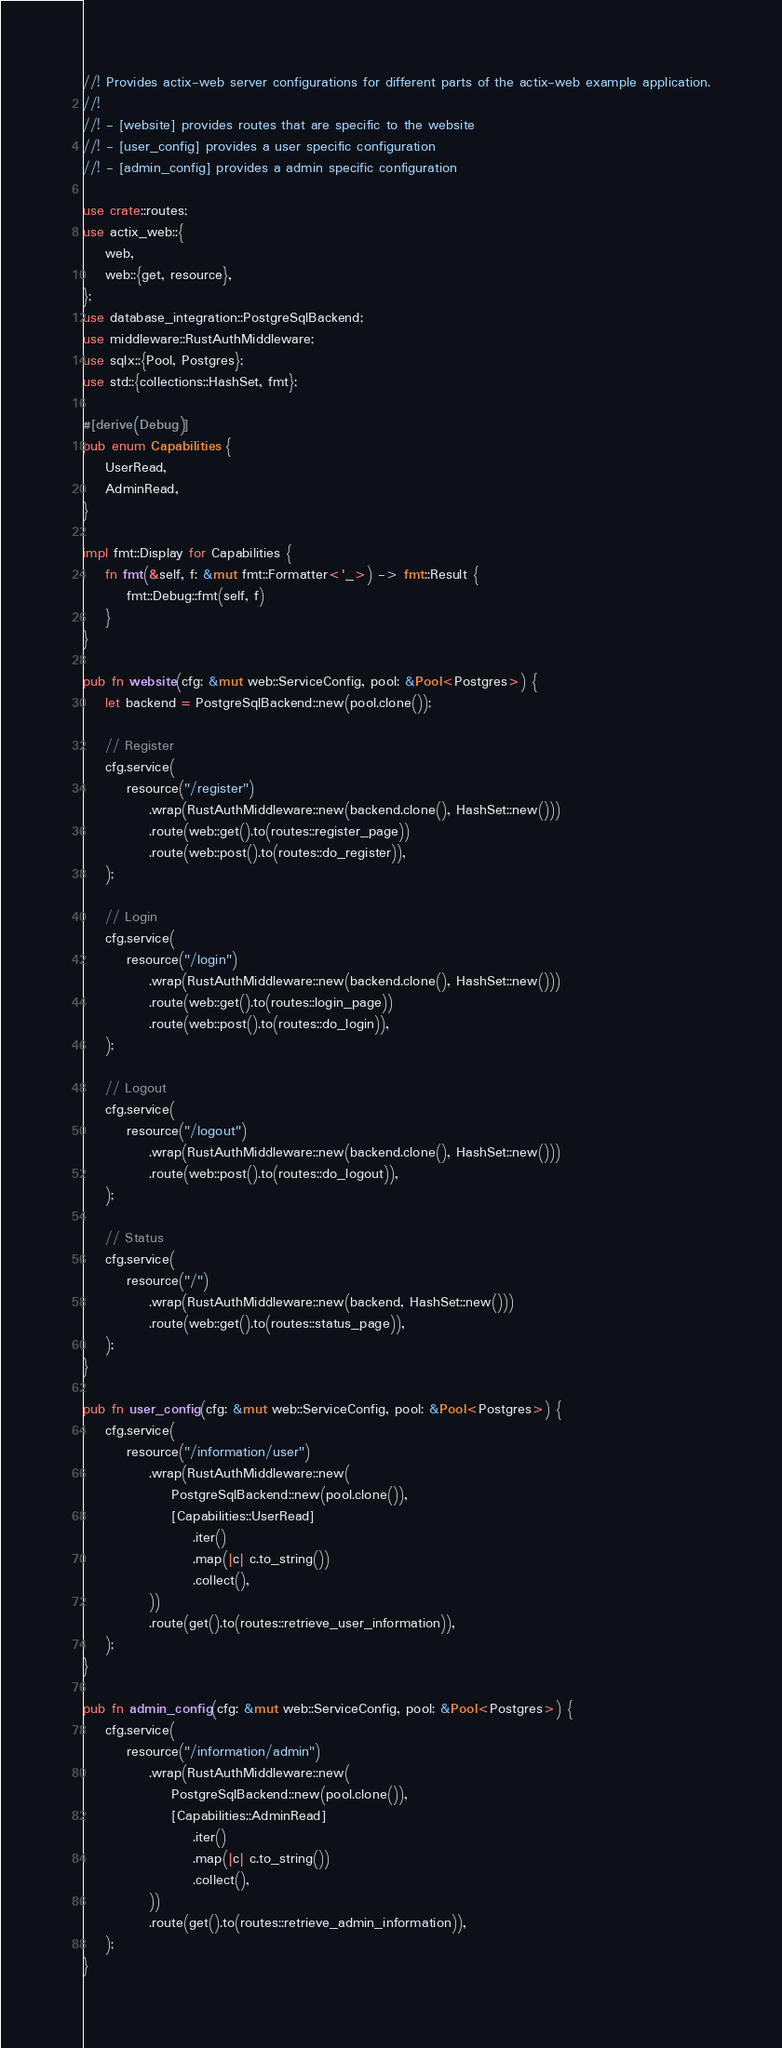<code> <loc_0><loc_0><loc_500><loc_500><_Rust_>//! Provides actix-web server configurations for different parts of the actix-web example application.
//!
//! - [website] provides routes that are specific to the website
//! - [user_config] provides a user specific configuration
//! - [admin_config] provides a admin specific configuration

use crate::routes;
use actix_web::{
    web,
    web::{get, resource},
};
use database_integration::PostgreSqlBackend;
use middleware::RustAuthMiddleware;
use sqlx::{Pool, Postgres};
use std::{collections::HashSet, fmt};

#[derive(Debug)]
pub enum Capabilities {
    UserRead,
    AdminRead,
}

impl fmt::Display for Capabilities {
    fn fmt(&self, f: &mut fmt::Formatter<'_>) -> fmt::Result {
        fmt::Debug::fmt(self, f)
    }
}

pub fn website(cfg: &mut web::ServiceConfig, pool: &Pool<Postgres>) {
    let backend = PostgreSqlBackend::new(pool.clone());

    // Register
    cfg.service(
        resource("/register")
            .wrap(RustAuthMiddleware::new(backend.clone(), HashSet::new()))
            .route(web::get().to(routes::register_page))
            .route(web::post().to(routes::do_register)),
    );

    // Login
    cfg.service(
        resource("/login")
            .wrap(RustAuthMiddleware::new(backend.clone(), HashSet::new()))
            .route(web::get().to(routes::login_page))
            .route(web::post().to(routes::do_login)),
    );

    // Logout
    cfg.service(
        resource("/logout")
            .wrap(RustAuthMiddleware::new(backend.clone(), HashSet::new()))
            .route(web::post().to(routes::do_logout)),
    );

    // Status
    cfg.service(
        resource("/")
            .wrap(RustAuthMiddleware::new(backend, HashSet::new()))
            .route(web::get().to(routes::status_page)),
    );
}

pub fn user_config(cfg: &mut web::ServiceConfig, pool: &Pool<Postgres>) {
    cfg.service(
        resource("/information/user")
            .wrap(RustAuthMiddleware::new(
                PostgreSqlBackend::new(pool.clone()),
                [Capabilities::UserRead]
                    .iter()
                    .map(|c| c.to_string())
                    .collect(),
            ))
            .route(get().to(routes::retrieve_user_information)),
    );
}

pub fn admin_config(cfg: &mut web::ServiceConfig, pool: &Pool<Postgres>) {
    cfg.service(
        resource("/information/admin")
            .wrap(RustAuthMiddleware::new(
                PostgreSqlBackend::new(pool.clone()),
                [Capabilities::AdminRead]
                    .iter()
                    .map(|c| c.to_string())
                    .collect(),
            ))
            .route(get().to(routes::retrieve_admin_information)),
    );
}
</code> 